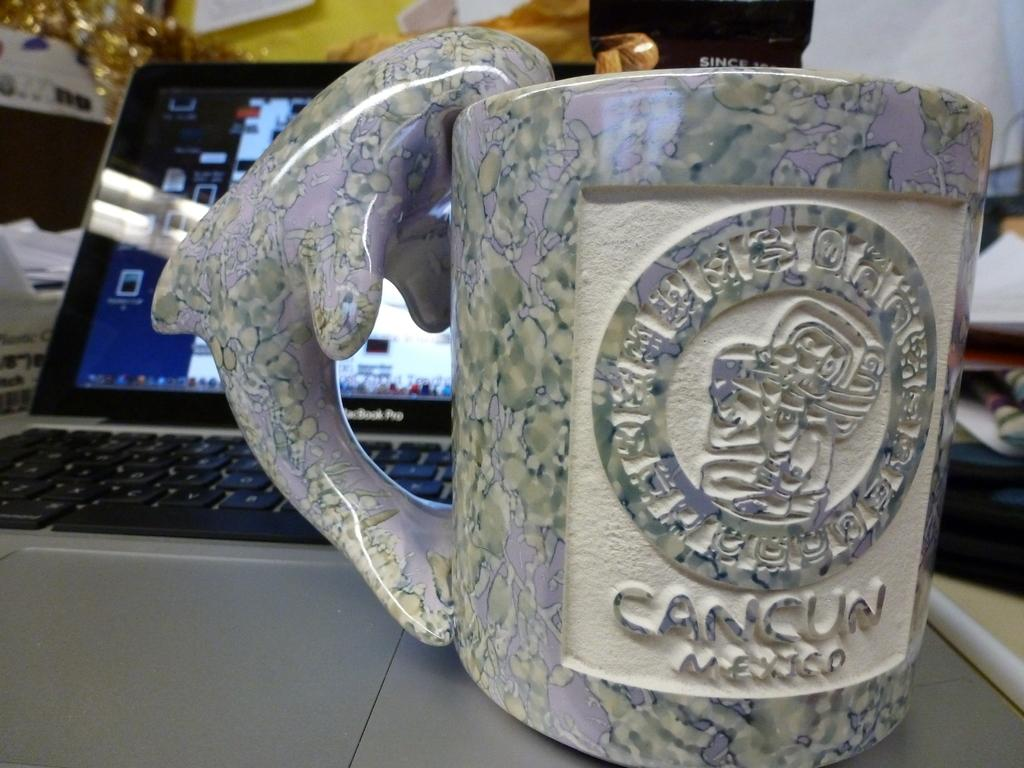<image>
Provide a brief description of the given image. A souvenir glass from Cancun is on top of a laptop. 